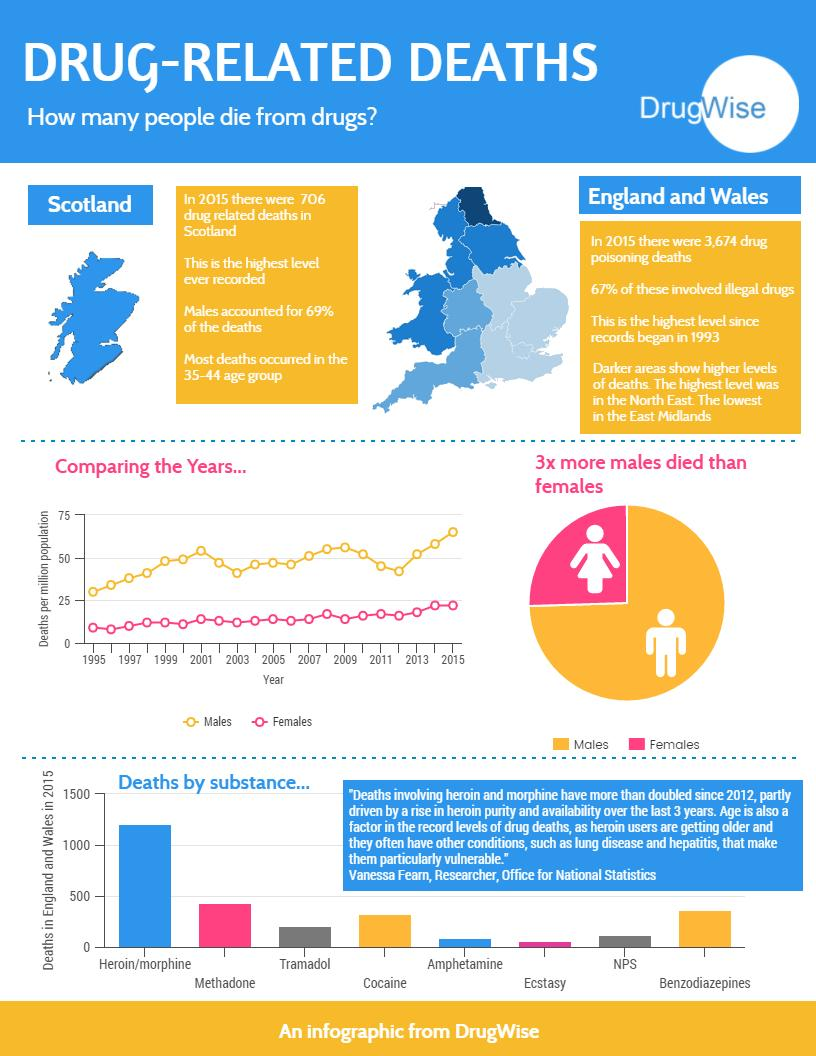Give some essential details in this illustration. The lowest death rate is for the substance known as ecstasy. There are 11 years depicted in the graph. In the context of the discussion, it was stated that "Which color is used to represent males-red, pink, orange, or blue? orange.. 